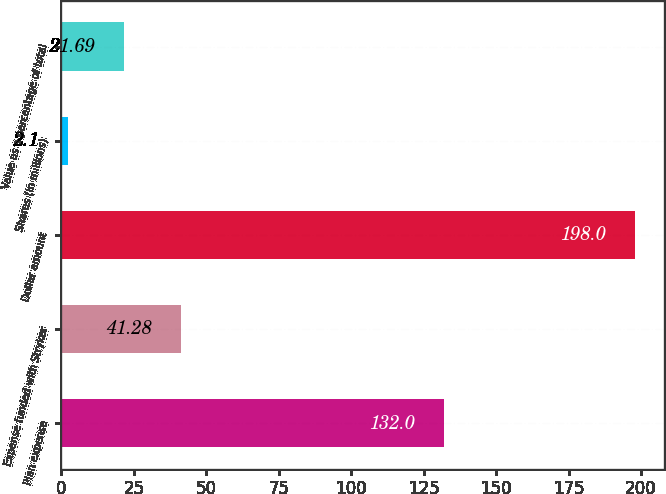<chart> <loc_0><loc_0><loc_500><loc_500><bar_chart><fcel>Plan expense<fcel>Expense funded with Stryker<fcel>Dollar amount<fcel>Shares (in millions)<fcel>Value as a percentage of total<nl><fcel>132<fcel>41.28<fcel>198<fcel>2.1<fcel>21.69<nl></chart> 